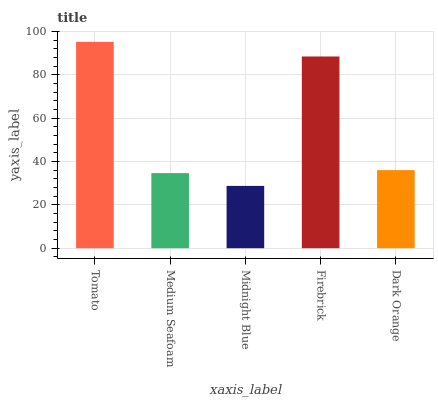Is Midnight Blue the minimum?
Answer yes or no. Yes. Is Tomato the maximum?
Answer yes or no. Yes. Is Medium Seafoam the minimum?
Answer yes or no. No. Is Medium Seafoam the maximum?
Answer yes or no. No. Is Tomato greater than Medium Seafoam?
Answer yes or no. Yes. Is Medium Seafoam less than Tomato?
Answer yes or no. Yes. Is Medium Seafoam greater than Tomato?
Answer yes or no. No. Is Tomato less than Medium Seafoam?
Answer yes or no. No. Is Dark Orange the high median?
Answer yes or no. Yes. Is Dark Orange the low median?
Answer yes or no. Yes. Is Midnight Blue the high median?
Answer yes or no. No. Is Tomato the low median?
Answer yes or no. No. 